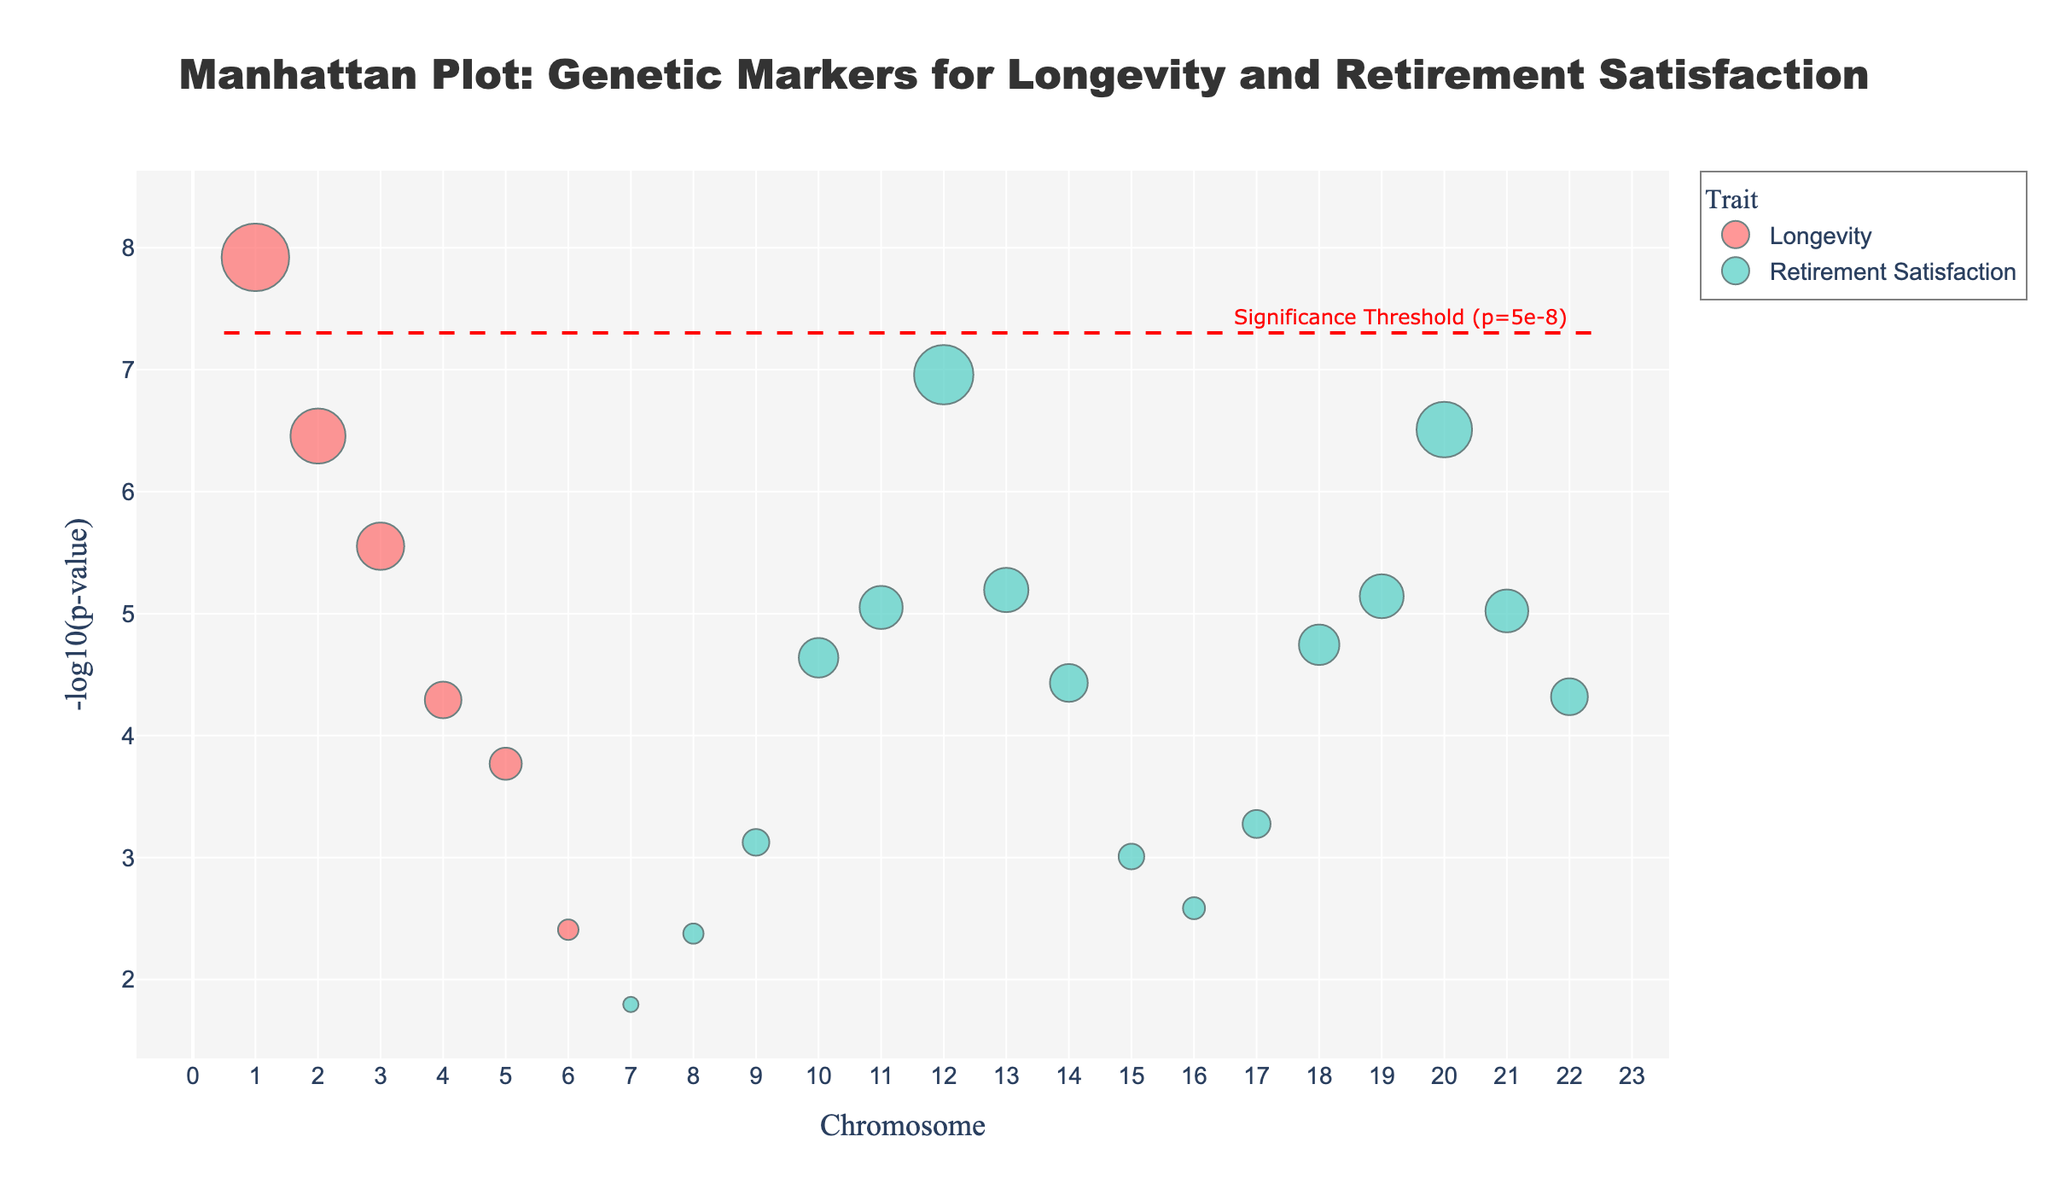How many genetic markers are associated with Longevity? Look at the colors represented in the plot. The markers associated with Longevity have one specific color. Count the number of genetic markers using that color.
Answer: 6 Which trait has the highest -log10(p-value) in the plot, and what is its value? Identify the highest point on the y-axis and check the corresponding trait color. Read off the -log10(p-value) from the y-axis.
Answer: Longevity, 8 Which gene associated with Retirement Satisfaction has the smallest p-value? Find the gene represented by the highest point among those colored for Retirement Satisfaction. The highest point corresponds to the smallest p-value.
Answer: DRD4 What is the significance threshold p-value shown on the plot? Locate the horizontal dashed line that represents the significance threshold. The annotation on the plot indicates this value.
Answer: p=5e-8 How many markers have a -log10(p-value) > 7? Look at the y-axis and identify all points above the -log10(p-value) of 7. Count these points.
Answer: 2 Which chromosome has the most genetic markers for Retirement Satisfaction? Check the x-axis, noting the chromosome numbers. Look for the chromosomes with the highest concentration of markers color-coded for Retirement Satisfaction and count them.
Answer: 12 Comparing Longevity and Retirement Satisfaction, which trait has more genetic markers below the significance threshold line? Visually compare the number of markers below the horizontal dashed line for each color representing Longevity and Retirement Satisfaction.
Answer: Retirement Satisfaction What is the gene with the highest -log10(p-value) on Chromosome 7? Identify the chromosome number on the x-axis and locate the highest marker on the y-axis for that specific chromosome. Check the gene associated with that point.
Answer: PTGS2 